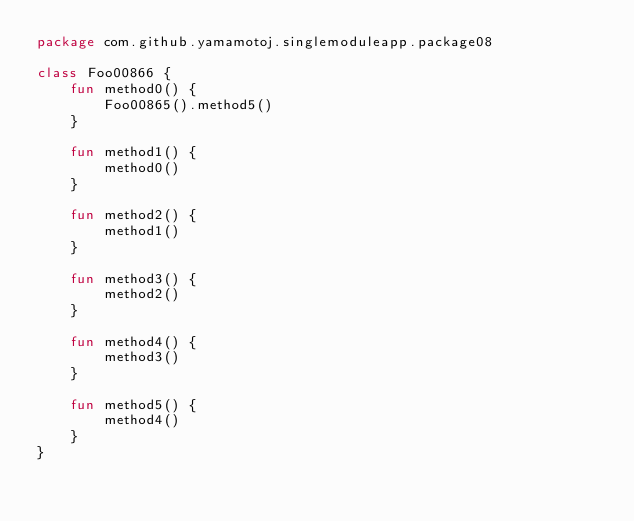Convert code to text. <code><loc_0><loc_0><loc_500><loc_500><_Kotlin_>package com.github.yamamotoj.singlemoduleapp.package08

class Foo00866 {
    fun method0() {
        Foo00865().method5()
    }

    fun method1() {
        method0()
    }

    fun method2() {
        method1()
    }

    fun method3() {
        method2()
    }

    fun method4() {
        method3()
    }

    fun method5() {
        method4()
    }
}
</code> 